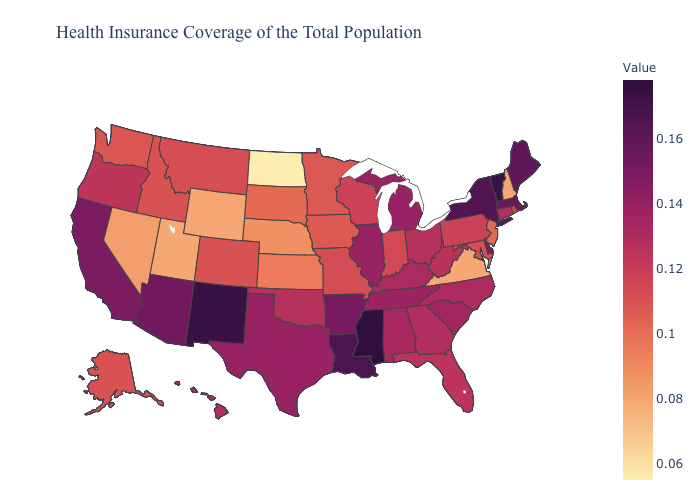Among the states that border Pennsylvania , does Ohio have the highest value?
Quick response, please. No. Among the states that border Illinois , which have the highest value?
Give a very brief answer. Kentucky. Does Mississippi have the highest value in the USA?
Answer briefly. Yes. Does Wyoming have the highest value in the USA?
Write a very short answer. No. Does Vermont have the lowest value in the Northeast?
Quick response, please. No. Does Maine have the lowest value in the Northeast?
Quick response, please. No. Does Minnesota have the highest value in the MidWest?
Keep it brief. No. Among the states that border Wyoming , which have the highest value?
Short answer required. Montana. 